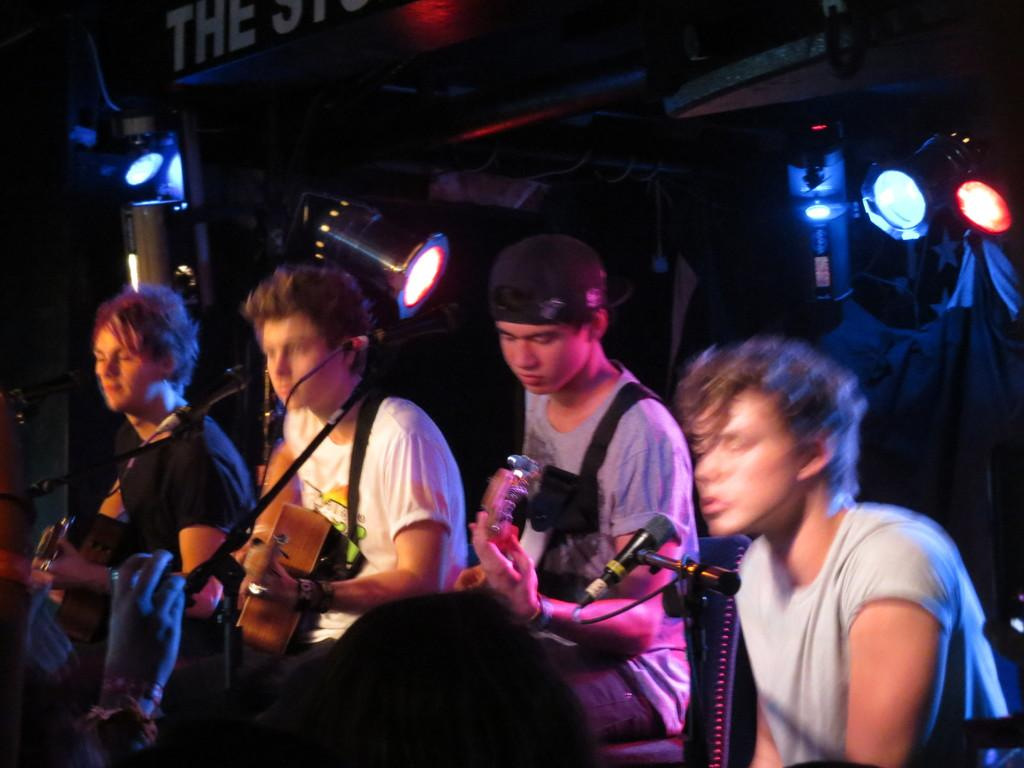How many people are in the image? There are four people in the image. What are the people doing in the image? The people are playing guitars, and one person is singing. Can you describe the singer's mouth in the image? The singer's mouth is slightly open. What can be seen in the background of the image? There are lights visible in the background. How does the society react to the person crying in the image? There is no person crying in the image; the people are playing guitars and singing. What action does the stop sign in the image instruct the people to take? There is no stop sign present in the image. 